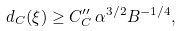Convert formula to latex. <formula><loc_0><loc_0><loc_500><loc_500>d _ { C } ( \xi ) \geq C _ { C } ^ { \prime \prime } \, \alpha ^ { 3 / 2 } B ^ { - 1 / 4 } ,</formula> 